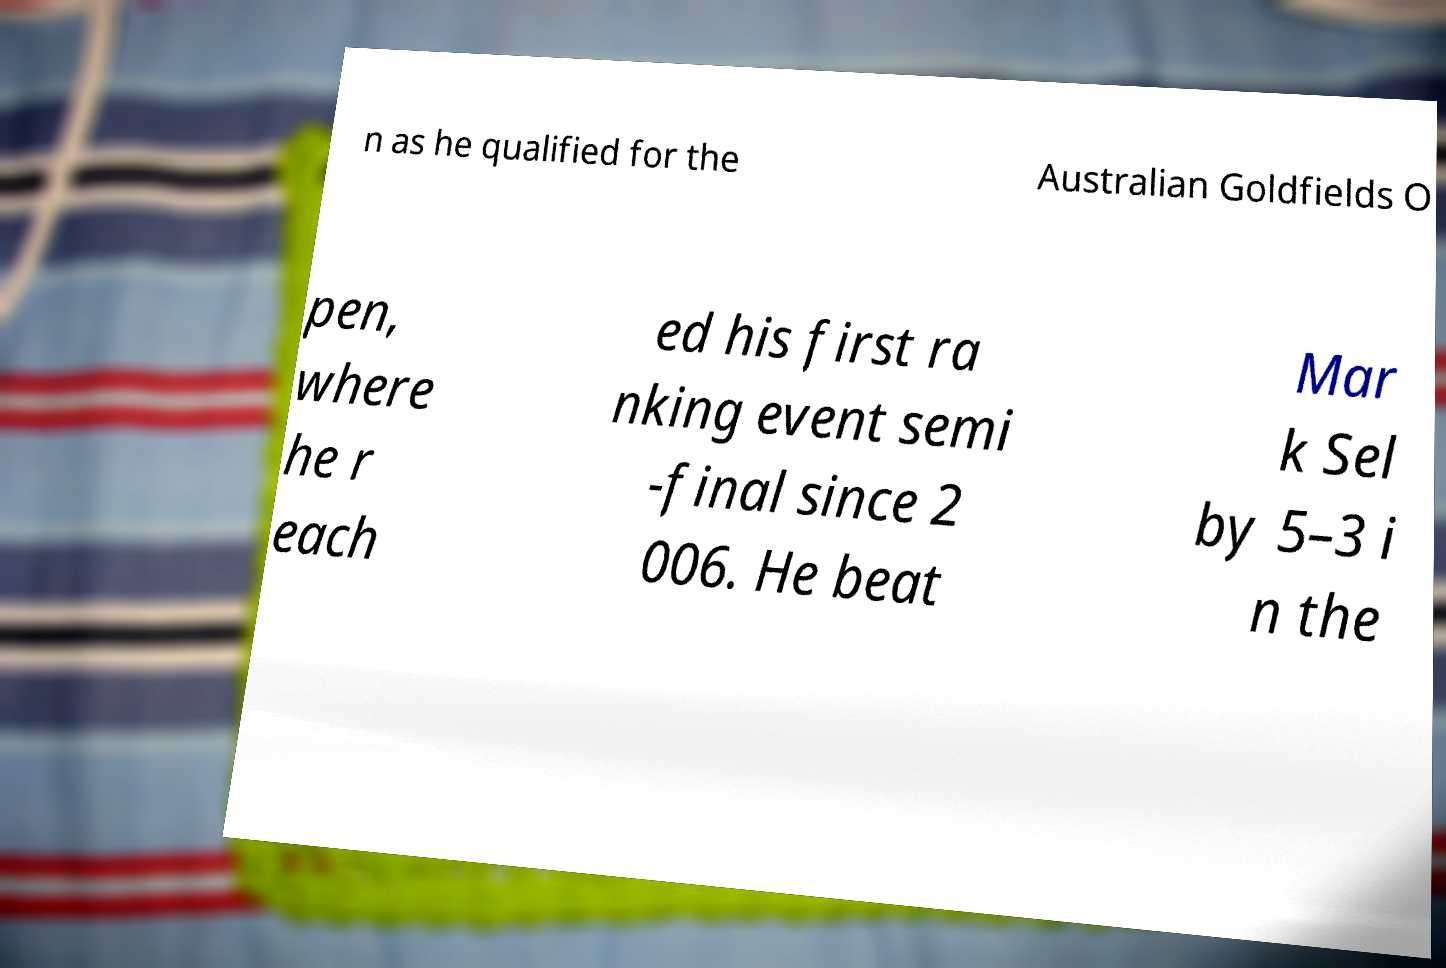Can you accurately transcribe the text from the provided image for me? n as he qualified for the Australian Goldfields O pen, where he r each ed his first ra nking event semi -final since 2 006. He beat Mar k Sel by 5–3 i n the 